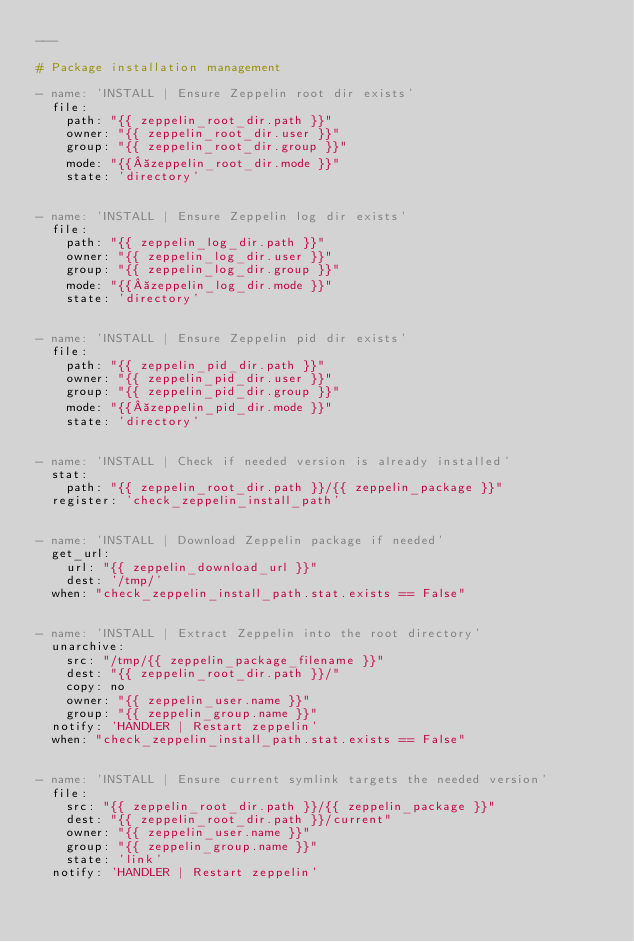Convert code to text. <code><loc_0><loc_0><loc_500><loc_500><_YAML_>---

# Package installation management

- name: 'INSTALL | Ensure Zeppelin root dir exists'
  file:
    path: "{{ zeppelin_root_dir.path }}"
    owner: "{{ zeppelin_root_dir.user }}"
    group: "{{ zeppelin_root_dir.group }}"
    mode: "{{ zeppelin_root_dir.mode }}"
    state: 'directory'


- name: 'INSTALL | Ensure Zeppelin log dir exists'
  file:
    path: "{{ zeppelin_log_dir.path }}"
    owner: "{{ zeppelin_log_dir.user }}"
    group: "{{ zeppelin_log_dir.group }}"
    mode: "{{ zeppelin_log_dir.mode }}"
    state: 'directory'


- name: 'INSTALL | Ensure Zeppelin pid dir exists'
  file:
    path: "{{ zeppelin_pid_dir.path }}"
    owner: "{{ zeppelin_pid_dir.user }}"
    group: "{{ zeppelin_pid_dir.group }}"
    mode: "{{ zeppelin_pid_dir.mode }}"
    state: 'directory'


- name: 'INSTALL | Check if needed version is already installed'
  stat:
    path: "{{ zeppelin_root_dir.path }}/{{ zeppelin_package }}"
  register: 'check_zeppelin_install_path'


- name: 'INSTALL | Download Zeppelin package if needed'
  get_url:
    url: "{{ zeppelin_download_url }}"
    dest: '/tmp/'
  when: "check_zeppelin_install_path.stat.exists == False"


- name: 'INSTALL | Extract Zeppelin into the root directory'
  unarchive:
    src: "/tmp/{{ zeppelin_package_filename }}"
    dest: "{{ zeppelin_root_dir.path }}/"
    copy: no
    owner: "{{ zeppelin_user.name }}"
    group: "{{ zeppelin_group.name }}"
  notify: 'HANDLER | Restart zeppelin'
  when: "check_zeppelin_install_path.stat.exists == False"


- name: 'INSTALL | Ensure current symlink targets the needed version'
  file:
    src: "{{ zeppelin_root_dir.path }}/{{ zeppelin_package }}"
    dest: "{{ zeppelin_root_dir.path }}/current"
    owner: "{{ zeppelin_user.name }}"
    group: "{{ zeppelin_group.name }}"
    state: 'link'
  notify: 'HANDLER | Restart zeppelin'
</code> 